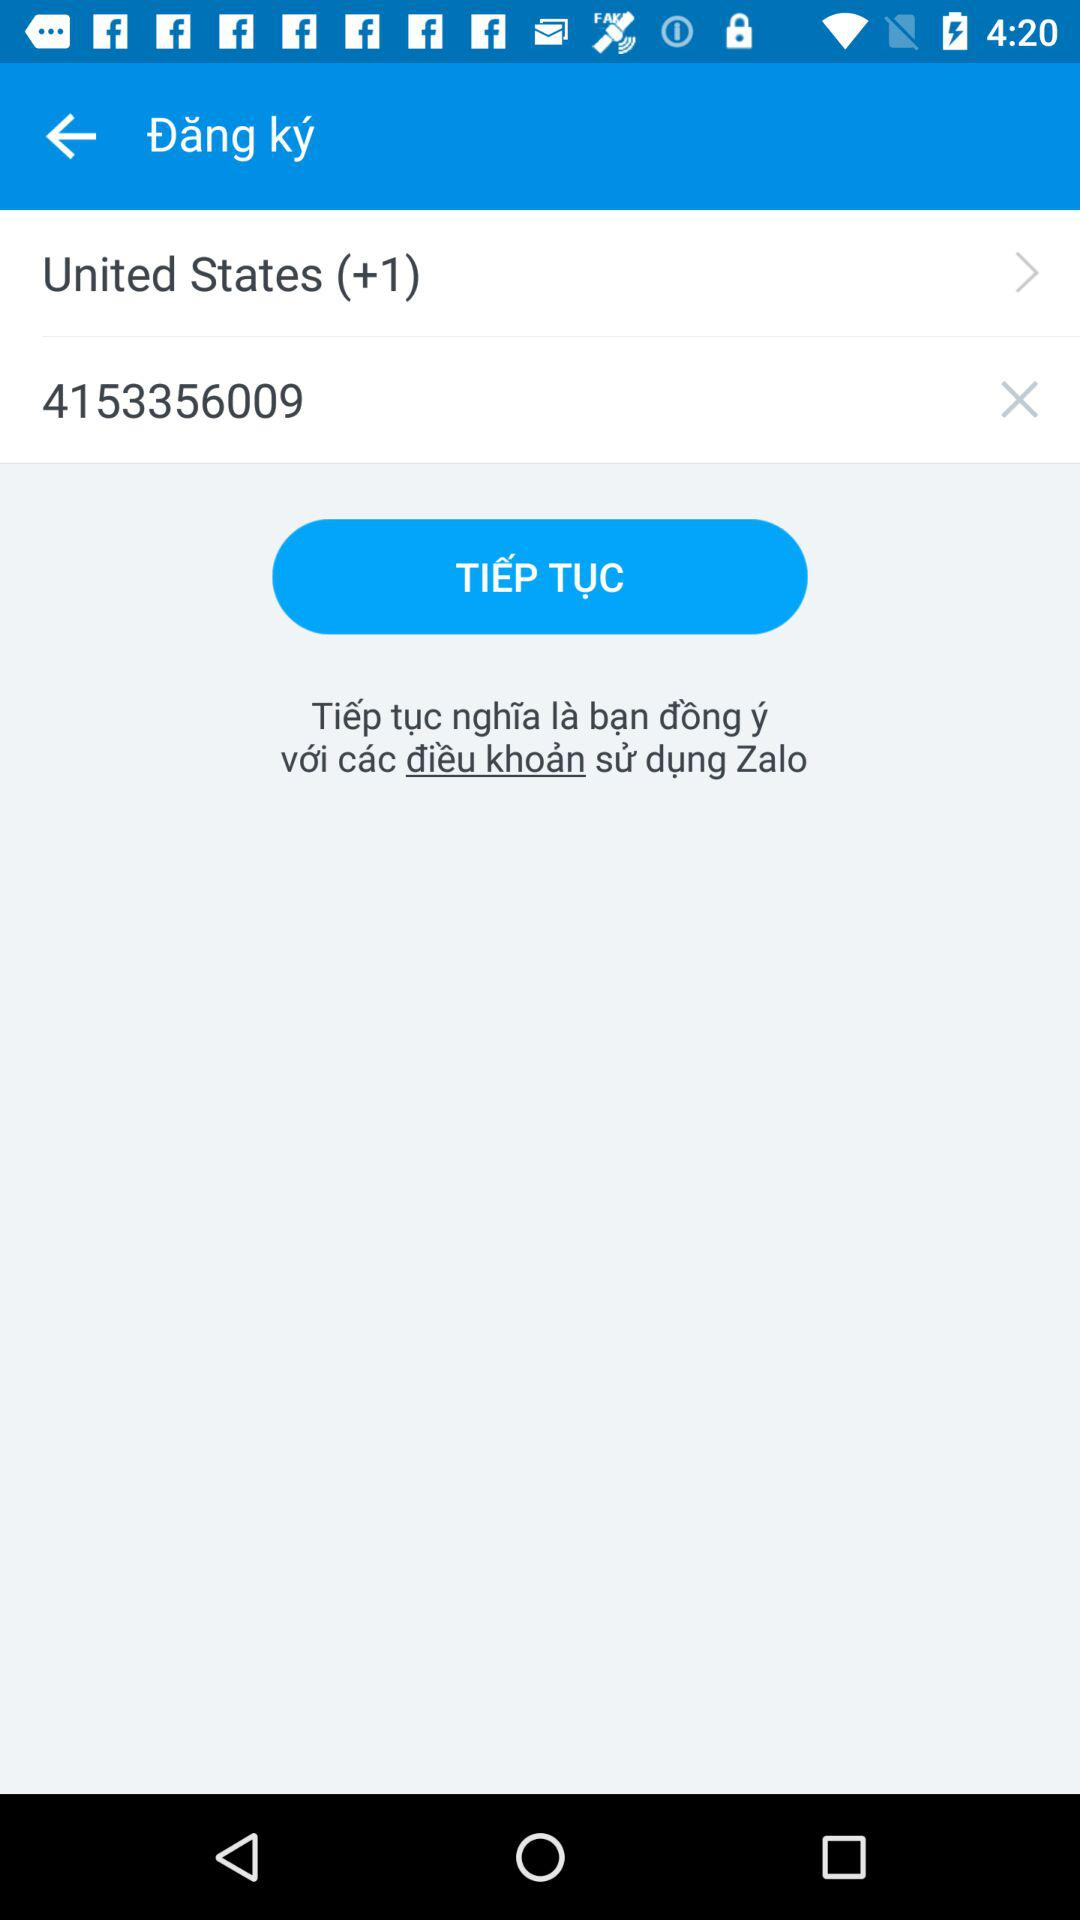How many digits are in the phone number?
Answer the question using a single word or phrase. 10 